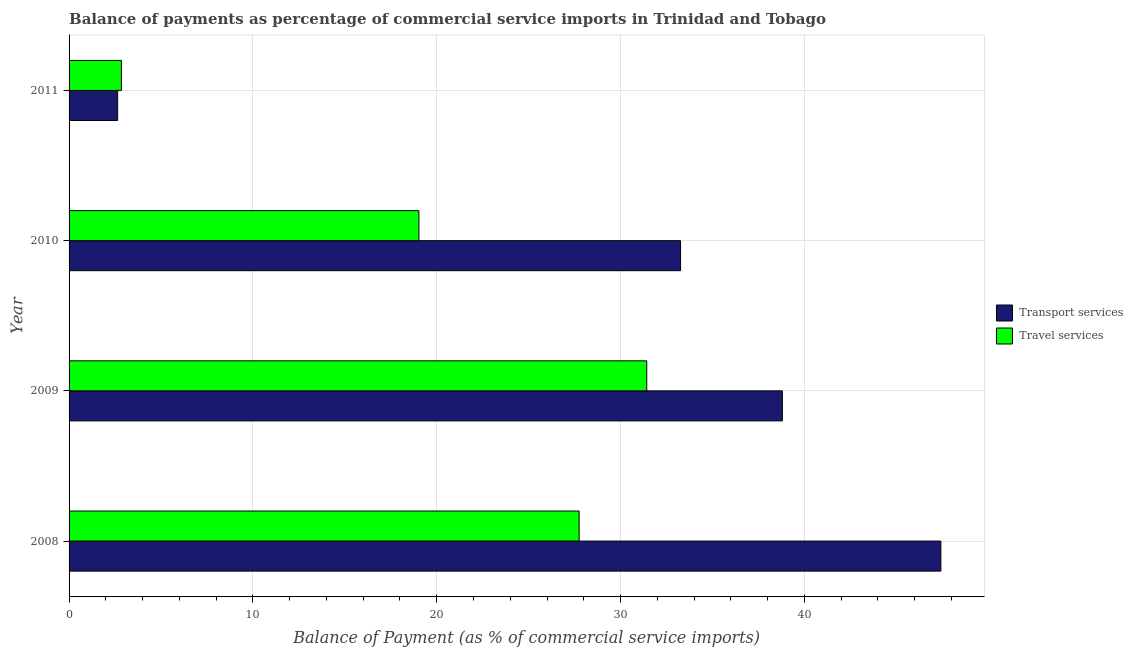How many different coloured bars are there?
Your answer should be very brief. 2. How many groups of bars are there?
Give a very brief answer. 4. Are the number of bars per tick equal to the number of legend labels?
Offer a very short reply. Yes. How many bars are there on the 2nd tick from the bottom?
Your answer should be compact. 2. In how many cases, is the number of bars for a given year not equal to the number of legend labels?
Offer a very short reply. 0. What is the balance of payments of transport services in 2009?
Offer a very short reply. 38.8. Across all years, what is the maximum balance of payments of travel services?
Make the answer very short. 31.42. Across all years, what is the minimum balance of payments of travel services?
Make the answer very short. 2.85. In which year was the balance of payments of travel services maximum?
Offer a very short reply. 2009. What is the total balance of payments of travel services in the graph?
Provide a succinct answer. 81.04. What is the difference between the balance of payments of travel services in 2009 and that in 2010?
Provide a short and direct response. 12.39. What is the difference between the balance of payments of travel services in 2008 and the balance of payments of transport services in 2009?
Keep it short and to the point. -11.05. What is the average balance of payments of travel services per year?
Give a very brief answer. 20.26. In the year 2009, what is the difference between the balance of payments of travel services and balance of payments of transport services?
Ensure brevity in your answer.  -7.38. What is the ratio of the balance of payments of travel services in 2008 to that in 2010?
Ensure brevity in your answer.  1.46. Is the balance of payments of travel services in 2008 less than that in 2010?
Offer a terse response. No. Is the difference between the balance of payments of travel services in 2008 and 2009 greater than the difference between the balance of payments of transport services in 2008 and 2009?
Your response must be concise. No. What is the difference between the highest and the second highest balance of payments of transport services?
Make the answer very short. 8.62. What is the difference between the highest and the lowest balance of payments of travel services?
Ensure brevity in your answer.  28.57. Is the sum of the balance of payments of transport services in 2010 and 2011 greater than the maximum balance of payments of travel services across all years?
Keep it short and to the point. Yes. What does the 1st bar from the top in 2011 represents?
Your answer should be compact. Travel services. What does the 1st bar from the bottom in 2009 represents?
Ensure brevity in your answer.  Transport services. Are the values on the major ticks of X-axis written in scientific E-notation?
Keep it short and to the point. No. Does the graph contain any zero values?
Provide a short and direct response. No. Does the graph contain grids?
Offer a very short reply. Yes. Where does the legend appear in the graph?
Your response must be concise. Center right. What is the title of the graph?
Make the answer very short. Balance of payments as percentage of commercial service imports in Trinidad and Tobago. What is the label or title of the X-axis?
Offer a terse response. Balance of Payment (as % of commercial service imports). What is the label or title of the Y-axis?
Your answer should be very brief. Year. What is the Balance of Payment (as % of commercial service imports) in Transport services in 2008?
Keep it short and to the point. 47.42. What is the Balance of Payment (as % of commercial service imports) in Travel services in 2008?
Make the answer very short. 27.75. What is the Balance of Payment (as % of commercial service imports) of Transport services in 2009?
Provide a short and direct response. 38.8. What is the Balance of Payment (as % of commercial service imports) in Travel services in 2009?
Keep it short and to the point. 31.42. What is the Balance of Payment (as % of commercial service imports) in Transport services in 2010?
Give a very brief answer. 33.26. What is the Balance of Payment (as % of commercial service imports) of Travel services in 2010?
Keep it short and to the point. 19.03. What is the Balance of Payment (as % of commercial service imports) in Transport services in 2011?
Ensure brevity in your answer.  2.64. What is the Balance of Payment (as % of commercial service imports) of Travel services in 2011?
Provide a succinct answer. 2.85. Across all years, what is the maximum Balance of Payment (as % of commercial service imports) in Transport services?
Provide a short and direct response. 47.42. Across all years, what is the maximum Balance of Payment (as % of commercial service imports) of Travel services?
Offer a very short reply. 31.42. Across all years, what is the minimum Balance of Payment (as % of commercial service imports) in Transport services?
Your response must be concise. 2.64. Across all years, what is the minimum Balance of Payment (as % of commercial service imports) in Travel services?
Make the answer very short. 2.85. What is the total Balance of Payment (as % of commercial service imports) of Transport services in the graph?
Ensure brevity in your answer.  122.12. What is the total Balance of Payment (as % of commercial service imports) in Travel services in the graph?
Provide a succinct answer. 81.04. What is the difference between the Balance of Payment (as % of commercial service imports) in Transport services in 2008 and that in 2009?
Offer a very short reply. 8.62. What is the difference between the Balance of Payment (as % of commercial service imports) in Travel services in 2008 and that in 2009?
Provide a short and direct response. -3.68. What is the difference between the Balance of Payment (as % of commercial service imports) in Transport services in 2008 and that in 2010?
Keep it short and to the point. 14.16. What is the difference between the Balance of Payment (as % of commercial service imports) in Travel services in 2008 and that in 2010?
Make the answer very short. 8.72. What is the difference between the Balance of Payment (as % of commercial service imports) in Transport services in 2008 and that in 2011?
Offer a terse response. 44.78. What is the difference between the Balance of Payment (as % of commercial service imports) in Travel services in 2008 and that in 2011?
Make the answer very short. 24.9. What is the difference between the Balance of Payment (as % of commercial service imports) in Transport services in 2009 and that in 2010?
Your answer should be very brief. 5.54. What is the difference between the Balance of Payment (as % of commercial service imports) in Travel services in 2009 and that in 2010?
Ensure brevity in your answer.  12.39. What is the difference between the Balance of Payment (as % of commercial service imports) in Transport services in 2009 and that in 2011?
Your response must be concise. 36.16. What is the difference between the Balance of Payment (as % of commercial service imports) of Travel services in 2009 and that in 2011?
Make the answer very short. 28.57. What is the difference between the Balance of Payment (as % of commercial service imports) of Transport services in 2010 and that in 2011?
Your answer should be very brief. 30.62. What is the difference between the Balance of Payment (as % of commercial service imports) of Travel services in 2010 and that in 2011?
Your response must be concise. 16.18. What is the difference between the Balance of Payment (as % of commercial service imports) in Transport services in 2008 and the Balance of Payment (as % of commercial service imports) in Travel services in 2009?
Give a very brief answer. 16. What is the difference between the Balance of Payment (as % of commercial service imports) of Transport services in 2008 and the Balance of Payment (as % of commercial service imports) of Travel services in 2010?
Make the answer very short. 28.39. What is the difference between the Balance of Payment (as % of commercial service imports) of Transport services in 2008 and the Balance of Payment (as % of commercial service imports) of Travel services in 2011?
Ensure brevity in your answer.  44.57. What is the difference between the Balance of Payment (as % of commercial service imports) of Transport services in 2009 and the Balance of Payment (as % of commercial service imports) of Travel services in 2010?
Offer a very short reply. 19.77. What is the difference between the Balance of Payment (as % of commercial service imports) in Transport services in 2009 and the Balance of Payment (as % of commercial service imports) in Travel services in 2011?
Your answer should be very brief. 35.95. What is the difference between the Balance of Payment (as % of commercial service imports) in Transport services in 2010 and the Balance of Payment (as % of commercial service imports) in Travel services in 2011?
Provide a short and direct response. 30.41. What is the average Balance of Payment (as % of commercial service imports) in Transport services per year?
Provide a succinct answer. 30.53. What is the average Balance of Payment (as % of commercial service imports) in Travel services per year?
Offer a very short reply. 20.26. In the year 2008, what is the difference between the Balance of Payment (as % of commercial service imports) of Transport services and Balance of Payment (as % of commercial service imports) of Travel services?
Keep it short and to the point. 19.68. In the year 2009, what is the difference between the Balance of Payment (as % of commercial service imports) of Transport services and Balance of Payment (as % of commercial service imports) of Travel services?
Offer a terse response. 7.38. In the year 2010, what is the difference between the Balance of Payment (as % of commercial service imports) of Transport services and Balance of Payment (as % of commercial service imports) of Travel services?
Your response must be concise. 14.23. In the year 2011, what is the difference between the Balance of Payment (as % of commercial service imports) in Transport services and Balance of Payment (as % of commercial service imports) in Travel services?
Your response must be concise. -0.2. What is the ratio of the Balance of Payment (as % of commercial service imports) of Transport services in 2008 to that in 2009?
Provide a short and direct response. 1.22. What is the ratio of the Balance of Payment (as % of commercial service imports) of Travel services in 2008 to that in 2009?
Offer a very short reply. 0.88. What is the ratio of the Balance of Payment (as % of commercial service imports) in Transport services in 2008 to that in 2010?
Provide a short and direct response. 1.43. What is the ratio of the Balance of Payment (as % of commercial service imports) of Travel services in 2008 to that in 2010?
Your answer should be compact. 1.46. What is the ratio of the Balance of Payment (as % of commercial service imports) of Transport services in 2008 to that in 2011?
Offer a very short reply. 17.95. What is the ratio of the Balance of Payment (as % of commercial service imports) of Travel services in 2008 to that in 2011?
Your answer should be very brief. 9.75. What is the ratio of the Balance of Payment (as % of commercial service imports) in Transport services in 2009 to that in 2010?
Offer a terse response. 1.17. What is the ratio of the Balance of Payment (as % of commercial service imports) of Travel services in 2009 to that in 2010?
Keep it short and to the point. 1.65. What is the ratio of the Balance of Payment (as % of commercial service imports) in Transport services in 2009 to that in 2011?
Keep it short and to the point. 14.68. What is the ratio of the Balance of Payment (as % of commercial service imports) of Travel services in 2009 to that in 2011?
Give a very brief answer. 11.04. What is the ratio of the Balance of Payment (as % of commercial service imports) in Transport services in 2010 to that in 2011?
Offer a terse response. 12.59. What is the ratio of the Balance of Payment (as % of commercial service imports) in Travel services in 2010 to that in 2011?
Your answer should be very brief. 6.68. What is the difference between the highest and the second highest Balance of Payment (as % of commercial service imports) in Transport services?
Your answer should be compact. 8.62. What is the difference between the highest and the second highest Balance of Payment (as % of commercial service imports) of Travel services?
Provide a short and direct response. 3.68. What is the difference between the highest and the lowest Balance of Payment (as % of commercial service imports) in Transport services?
Provide a short and direct response. 44.78. What is the difference between the highest and the lowest Balance of Payment (as % of commercial service imports) in Travel services?
Your answer should be very brief. 28.57. 